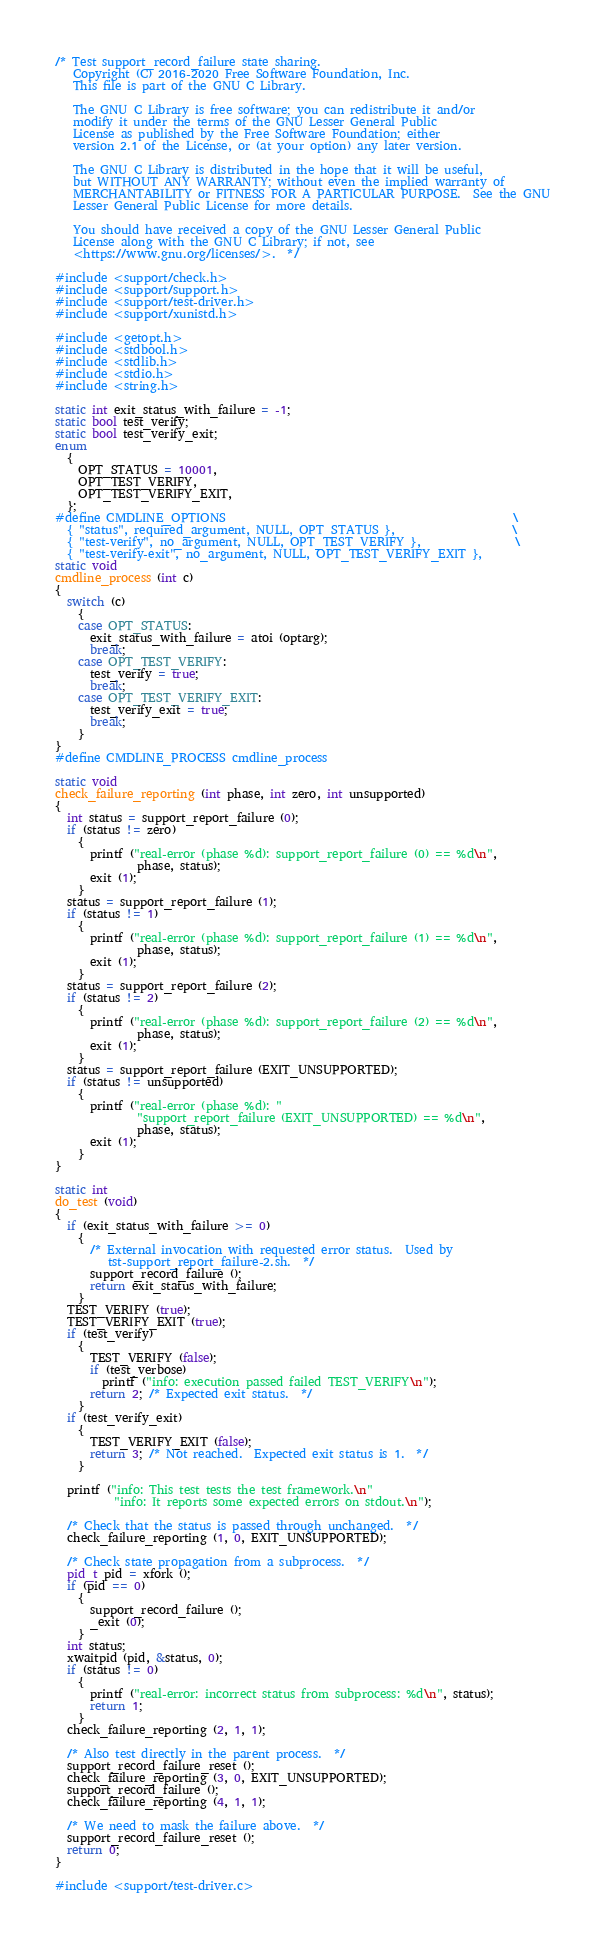<code> <loc_0><loc_0><loc_500><loc_500><_C_>/* Test support_record_failure state sharing.
   Copyright (C) 2016-2020 Free Software Foundation, Inc.
   This file is part of the GNU C Library.

   The GNU C Library is free software; you can redistribute it and/or
   modify it under the terms of the GNU Lesser General Public
   License as published by the Free Software Foundation; either
   version 2.1 of the License, or (at your option) any later version.

   The GNU C Library is distributed in the hope that it will be useful,
   but WITHOUT ANY WARRANTY; without even the implied warranty of
   MERCHANTABILITY or FITNESS FOR A PARTICULAR PURPOSE.  See the GNU
   Lesser General Public License for more details.

   You should have received a copy of the GNU Lesser General Public
   License along with the GNU C Library; if not, see
   <https://www.gnu.org/licenses/>.  */

#include <support/check.h>
#include <support/support.h>
#include <support/test-driver.h>
#include <support/xunistd.h>

#include <getopt.h>
#include <stdbool.h>
#include <stdlib.h>
#include <stdio.h>
#include <string.h>

static int exit_status_with_failure = -1;
static bool test_verify;
static bool test_verify_exit;
enum
  {
    OPT_STATUS = 10001,
    OPT_TEST_VERIFY,
    OPT_TEST_VERIFY_EXIT,
  };
#define CMDLINE_OPTIONS                                                 \
  { "status", required_argument, NULL, OPT_STATUS },                    \
  { "test-verify", no_argument, NULL, OPT_TEST_VERIFY },                \
  { "test-verify-exit", no_argument, NULL, OPT_TEST_VERIFY_EXIT },
static void
cmdline_process (int c)
{
  switch (c)
    {
    case OPT_STATUS:
      exit_status_with_failure = atoi (optarg);
      break;
    case OPT_TEST_VERIFY:
      test_verify = true;
      break;
    case OPT_TEST_VERIFY_EXIT:
      test_verify_exit = true;
      break;
    }
}
#define CMDLINE_PROCESS cmdline_process

static void
check_failure_reporting (int phase, int zero, int unsupported)
{
  int status = support_report_failure (0);
  if (status != zero)
    {
      printf ("real-error (phase %d): support_report_failure (0) == %d\n",
              phase, status);
      exit (1);
    }
  status = support_report_failure (1);
  if (status != 1)
    {
      printf ("real-error (phase %d): support_report_failure (1) == %d\n",
              phase, status);
      exit (1);
    }
  status = support_report_failure (2);
  if (status != 2)
    {
      printf ("real-error (phase %d): support_report_failure (2) == %d\n",
              phase, status);
      exit (1);
    }
  status = support_report_failure (EXIT_UNSUPPORTED);
  if (status != unsupported)
    {
      printf ("real-error (phase %d): "
              "support_report_failure (EXIT_UNSUPPORTED) == %d\n",
              phase, status);
      exit (1);
    }
}

static int
do_test (void)
{
  if (exit_status_with_failure >= 0)
    {
      /* External invocation with requested error status.  Used by
         tst-support_report_failure-2.sh.  */
      support_record_failure ();
      return exit_status_with_failure;
    }
  TEST_VERIFY (true);
  TEST_VERIFY_EXIT (true);
  if (test_verify)
    {
      TEST_VERIFY (false);
      if (test_verbose)
        printf ("info: execution passed failed TEST_VERIFY\n");
      return 2; /* Expected exit status.  */
    }
  if (test_verify_exit)
    {
      TEST_VERIFY_EXIT (false);
      return 3; /* Not reached.  Expected exit status is 1.  */
    }

  printf ("info: This test tests the test framework.\n"
          "info: It reports some expected errors on stdout.\n");

  /* Check that the status is passed through unchanged.  */
  check_failure_reporting (1, 0, EXIT_UNSUPPORTED);

  /* Check state propagation from a subprocess.  */
  pid_t pid = xfork ();
  if (pid == 0)
    {
      support_record_failure ();
      _exit (0);
    }
  int status;
  xwaitpid (pid, &status, 0);
  if (status != 0)
    {
      printf ("real-error: incorrect status from subprocess: %d\n", status);
      return 1;
    }
  check_failure_reporting (2, 1, 1);

  /* Also test directly in the parent process.  */
  support_record_failure_reset ();
  check_failure_reporting (3, 0, EXIT_UNSUPPORTED);
  support_record_failure ();
  check_failure_reporting (4, 1, 1);

  /* We need to mask the failure above.  */
  support_record_failure_reset ();
  return 0;
}

#include <support/test-driver.c>
</code> 